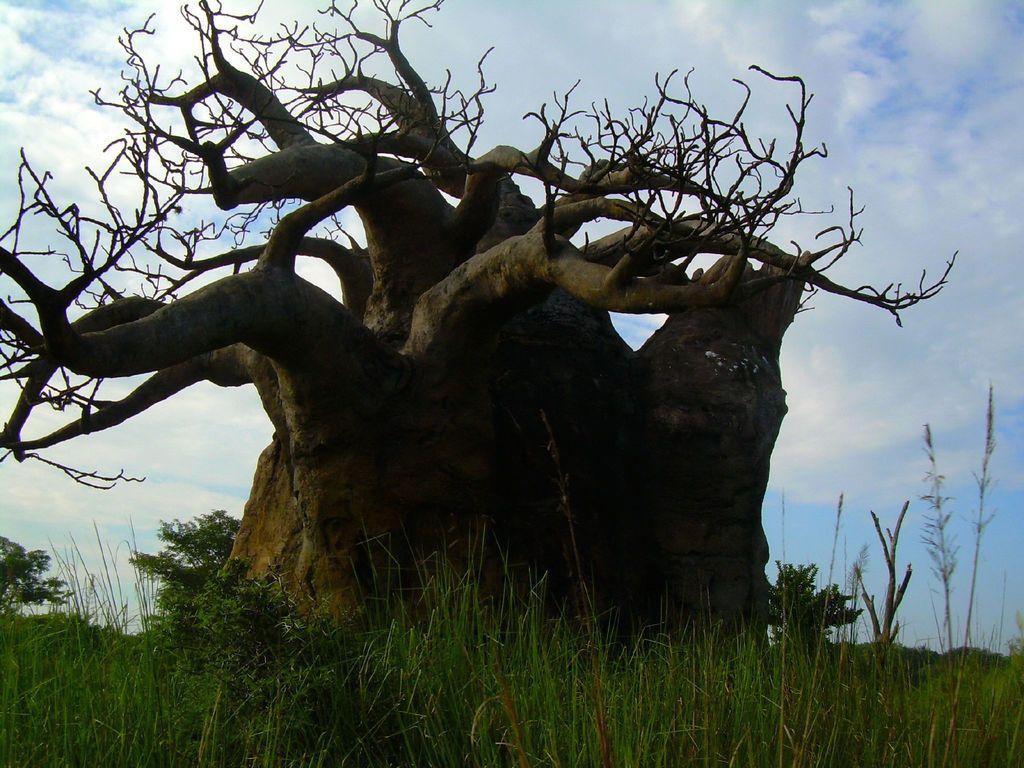Describe this image in one or two sentences. In the image there is a tree in the middle of the grassland and above its sky with clouds. 